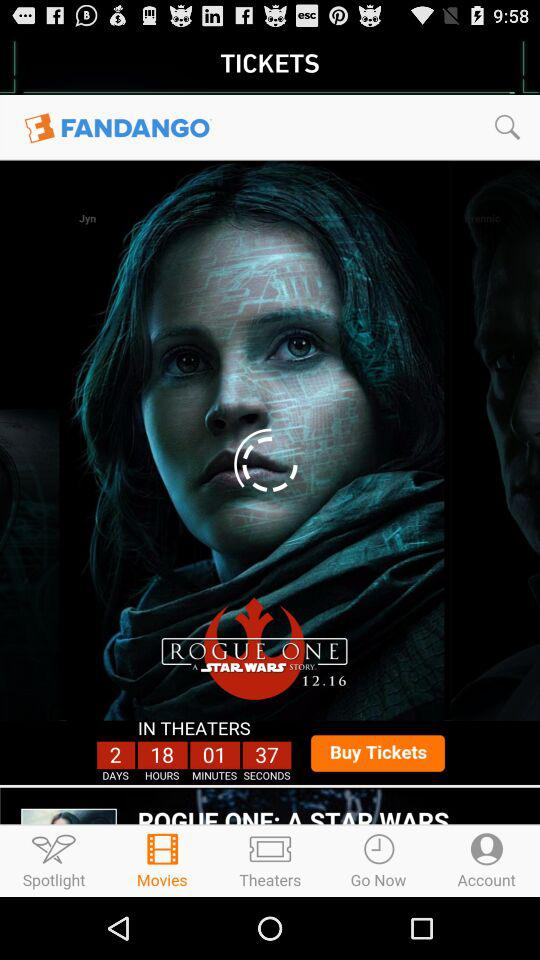Which tab am I on? You are on the "Movies" tab. 